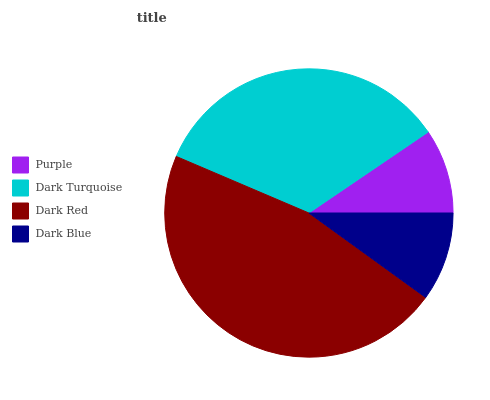Is Purple the minimum?
Answer yes or no. Yes. Is Dark Red the maximum?
Answer yes or no. Yes. Is Dark Turquoise the minimum?
Answer yes or no. No. Is Dark Turquoise the maximum?
Answer yes or no. No. Is Dark Turquoise greater than Purple?
Answer yes or no. Yes. Is Purple less than Dark Turquoise?
Answer yes or no. Yes. Is Purple greater than Dark Turquoise?
Answer yes or no. No. Is Dark Turquoise less than Purple?
Answer yes or no. No. Is Dark Turquoise the high median?
Answer yes or no. Yes. Is Dark Blue the low median?
Answer yes or no. Yes. Is Dark Blue the high median?
Answer yes or no. No. Is Dark Turquoise the low median?
Answer yes or no. No. 